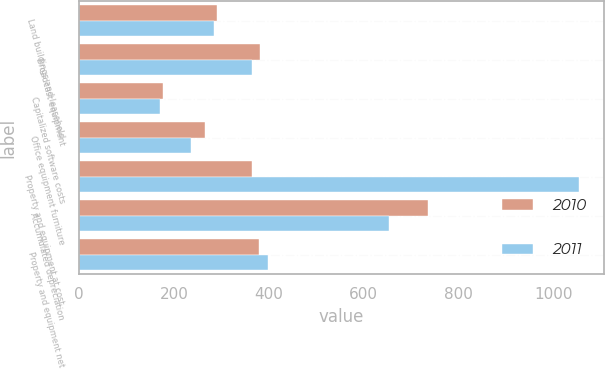Convert chart. <chart><loc_0><loc_0><loc_500><loc_500><stacked_bar_chart><ecel><fcel>Land buildings and leasehold<fcel>Broadcast equipment<fcel>Capitalized software costs<fcel>Office equipment furniture<fcel>Property and equipment at cost<fcel>Accumulated depreciation<fcel>Property and equipment net<nl><fcel>2010<fcel>290<fcel>381<fcel>178<fcel>266<fcel>364<fcel>736<fcel>379<nl><fcel>2011<fcel>284<fcel>364<fcel>170<fcel>235<fcel>1053<fcel>654<fcel>399<nl></chart> 